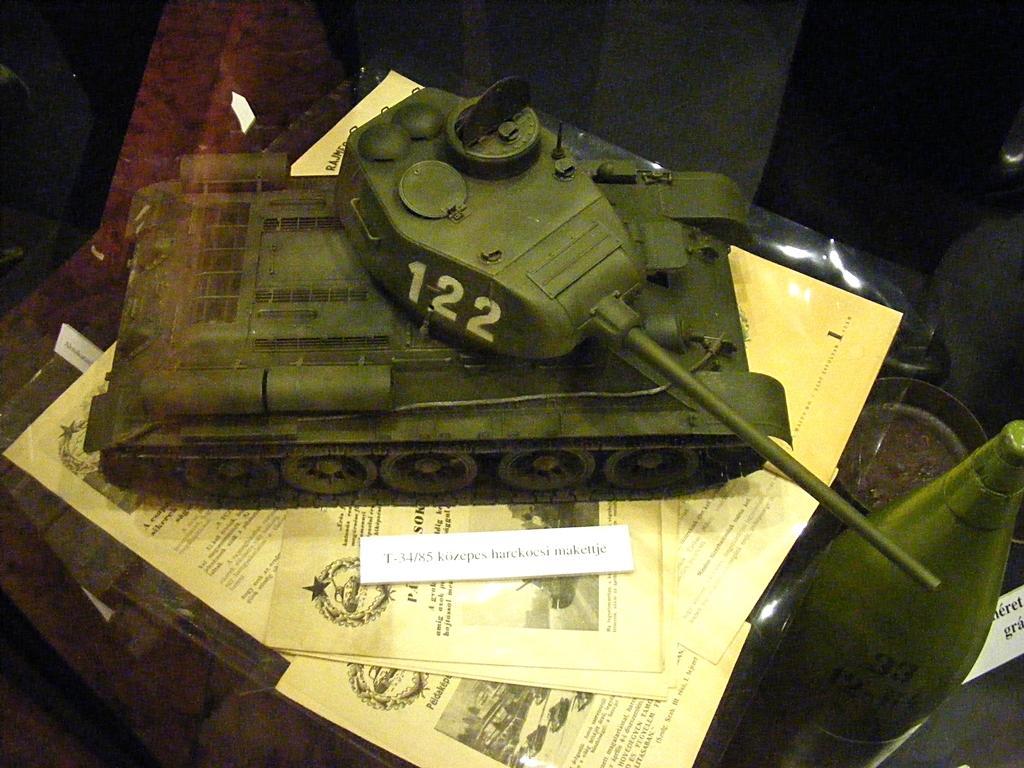Could you give a brief overview of what you see in this image? In this picture we can see papers, armored car and some objects and in the background it is dark. 